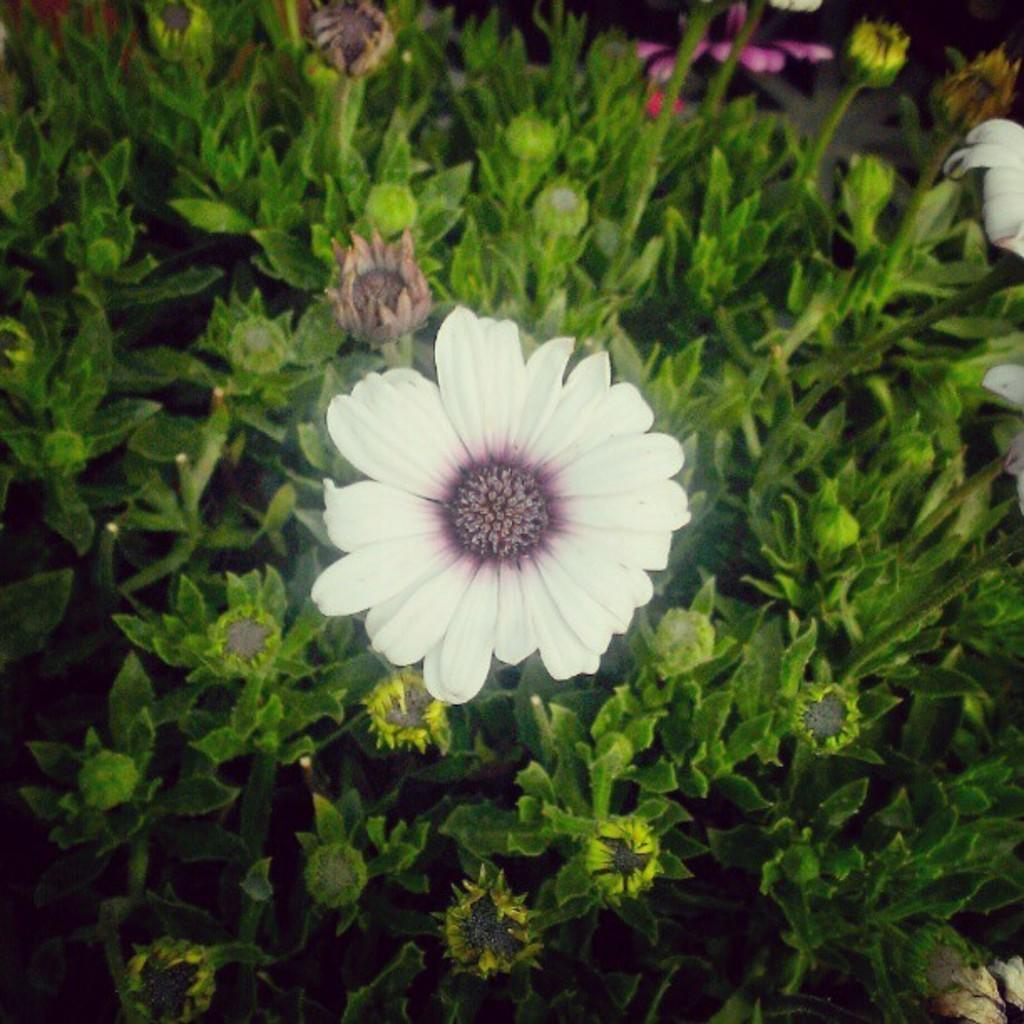What type of flower is in the image? There is a white flower in the image. What can be seen in the background of the image? There are plants with buds in the background of the image. Is there a stream flowing through the field in the image? There is no mention of a field or stream in the image; it only features a white flower and plants with buds in the background. 